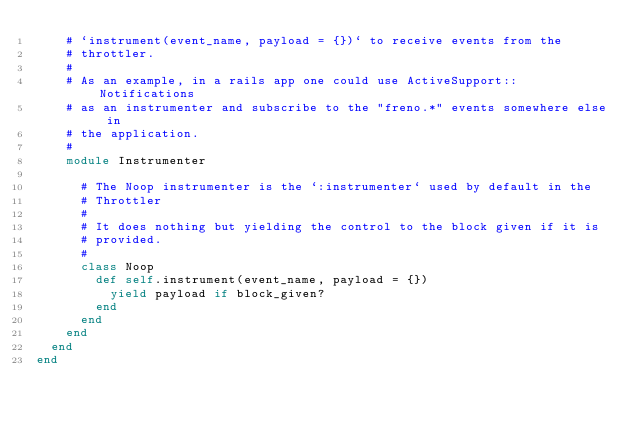<code> <loc_0><loc_0><loc_500><loc_500><_Ruby_>    # `instrument(event_name, payload = {})` to receive events from the
    # throttler.
    #
    # As an example, in a rails app one could use ActiveSupport::Notifications
    # as an instrumenter and subscribe to the "freno.*" events somewhere else in
    # the application.
    #
    module Instrumenter

      # The Noop instrumenter is the `:instrumenter` used by default in the
      # Throttler
      #
      # It does nothing but yielding the control to the block given if it is
      # provided.
      #
      class Noop
        def self.instrument(event_name, payload = {})
          yield payload if block_given?
        end
      end
    end
  end
end
</code> 